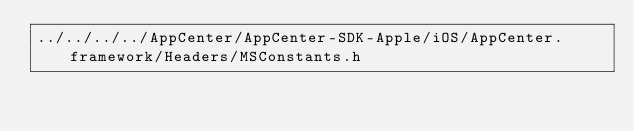Convert code to text. <code><loc_0><loc_0><loc_500><loc_500><_C_>../../../../AppCenter/AppCenter-SDK-Apple/iOS/AppCenter.framework/Headers/MSConstants.h</code> 